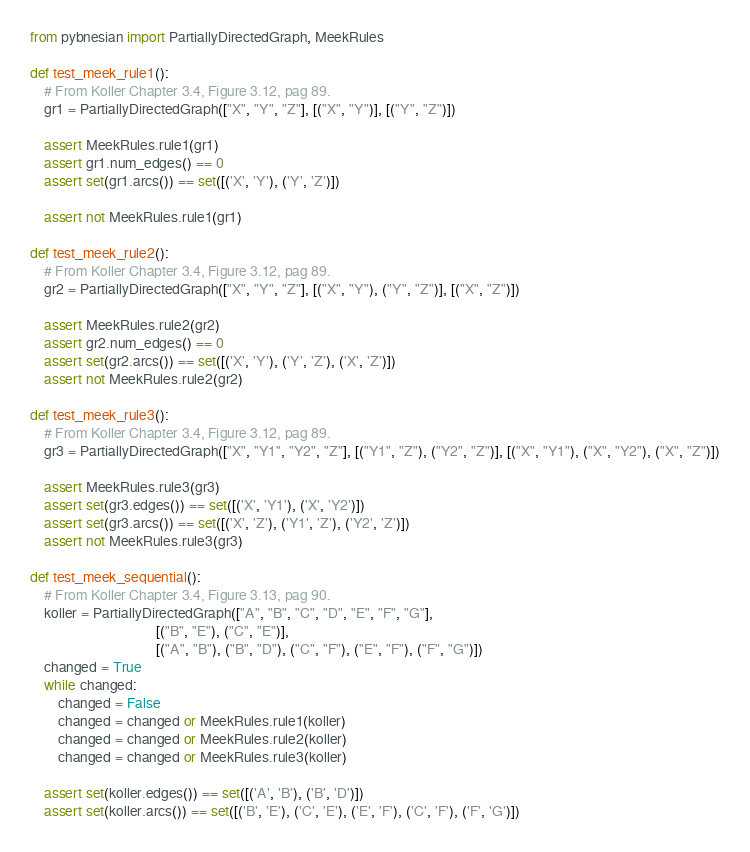Convert code to text. <code><loc_0><loc_0><loc_500><loc_500><_Python_>from pybnesian import PartiallyDirectedGraph, MeekRules

def test_meek_rule1():
    # From Koller Chapter 3.4, Figure 3.12, pag 89.
    gr1 = PartiallyDirectedGraph(["X", "Y", "Z"], [("X", "Y")], [("Y", "Z")])

    assert MeekRules.rule1(gr1)
    assert gr1.num_edges() == 0
    assert set(gr1.arcs()) == set([('X', 'Y'), ('Y', 'Z')])

    assert not MeekRules.rule1(gr1)

def test_meek_rule2():
    # From Koller Chapter 3.4, Figure 3.12, pag 89.
    gr2 = PartiallyDirectedGraph(["X", "Y", "Z"], [("X", "Y"), ("Y", "Z")], [("X", "Z")])

    assert MeekRules.rule2(gr2)
    assert gr2.num_edges() == 0
    assert set(gr2.arcs()) == set([('X', 'Y'), ('Y', 'Z'), ('X', 'Z')])
    assert not MeekRules.rule2(gr2)

def test_meek_rule3():
    # From Koller Chapter 3.4, Figure 3.12, pag 89.
    gr3 = PartiallyDirectedGraph(["X", "Y1", "Y2", "Z"], [("Y1", "Z"), ("Y2", "Z")], [("X", "Y1"), ("X", "Y2"), ("X", "Z")])

    assert MeekRules.rule3(gr3)
    assert set(gr3.edges()) == set([('X', 'Y1'), ('X', 'Y2')])
    assert set(gr3.arcs()) == set([('X', 'Z'), ('Y1', 'Z'), ('Y2', 'Z')])
    assert not MeekRules.rule3(gr3)

def test_meek_sequential():
    # From Koller Chapter 3.4, Figure 3.13, pag 90.
    koller = PartiallyDirectedGraph(["A", "B", "C", "D", "E", "F", "G"], 
                                    [("B", "E"), ("C", "E")],
                                    [("A", "B"), ("B", "D"), ("C", "F"), ("E", "F"), ("F", "G")])
    changed = True
    while changed:
        changed = False
        changed = changed or MeekRules.rule1(koller)
        changed = changed or MeekRules.rule2(koller)
        changed = changed or MeekRules.rule3(koller)

    assert set(koller.edges()) == set([('A', 'B'), ('B', 'D')])
    assert set(koller.arcs()) == set([('B', 'E'), ('C', 'E'), ('E', 'F'), ('C', 'F'), ('F', 'G')])</code> 